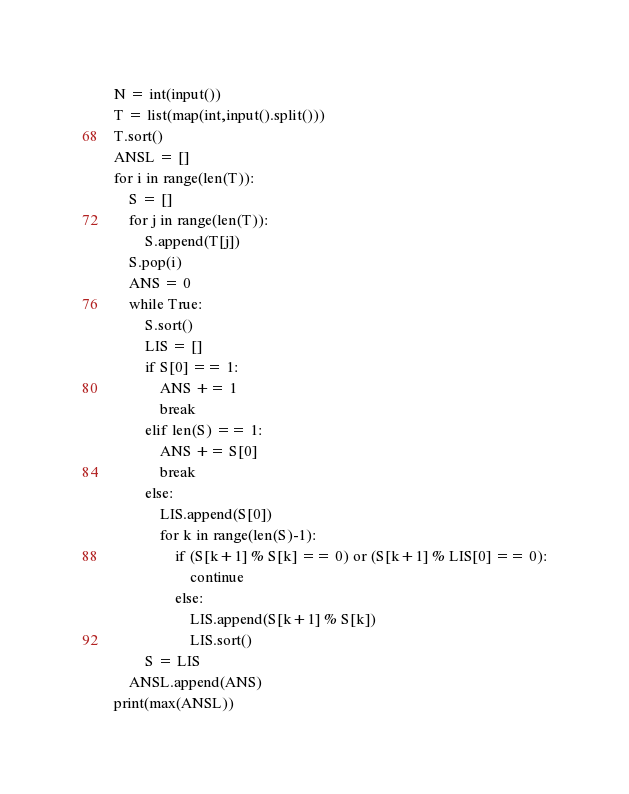Convert code to text. <code><loc_0><loc_0><loc_500><loc_500><_Python_>N = int(input())
T = list(map(int,input().split()))
T.sort()
ANSL = []
for i in range(len(T)):
    S = []
    for j in range(len(T)):
        S.append(T[j])
    S.pop(i)
    ANS = 0
    while True:
        S.sort()
        LIS = []
        if S[0] == 1:
            ANS += 1
            break
        elif len(S) == 1:
            ANS += S[0]
            break
        else:
            LIS.append(S[0])
            for k in range(len(S)-1):
                if (S[k+1] % S[k] == 0) or (S[k+1] % LIS[0] == 0):
                    continue
                else:
                    LIS.append(S[k+1] % S[k])
                    LIS.sort()
        S = LIS
    ANSL.append(ANS)
print(max(ANSL))
</code> 